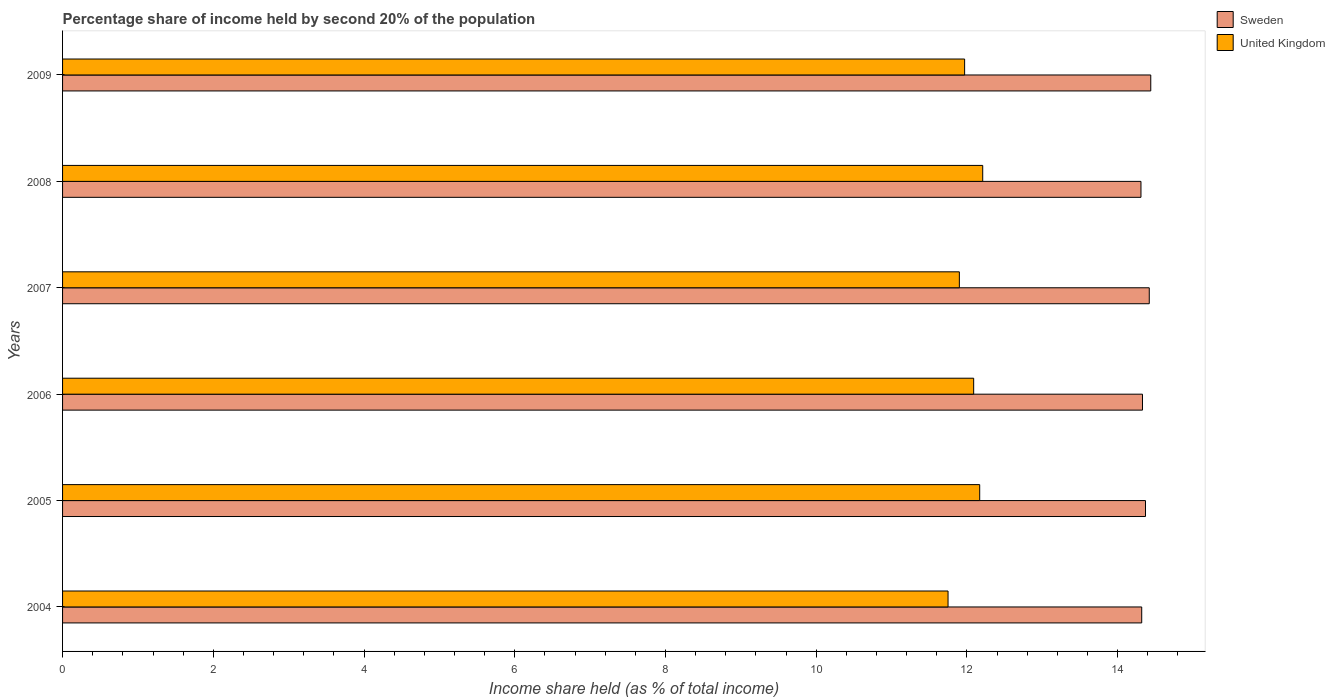How many different coloured bars are there?
Offer a very short reply. 2. How many groups of bars are there?
Your answer should be very brief. 6. Are the number of bars on each tick of the Y-axis equal?
Keep it short and to the point. Yes. How many bars are there on the 5th tick from the top?
Ensure brevity in your answer.  2. How many bars are there on the 5th tick from the bottom?
Your response must be concise. 2. In how many cases, is the number of bars for a given year not equal to the number of legend labels?
Keep it short and to the point. 0. What is the share of income held by second 20% of the population in Sweden in 2004?
Your response must be concise. 14.32. Across all years, what is the maximum share of income held by second 20% of the population in Sweden?
Offer a terse response. 14.44. Across all years, what is the minimum share of income held by second 20% of the population in United Kingdom?
Ensure brevity in your answer.  11.75. In which year was the share of income held by second 20% of the population in United Kingdom minimum?
Ensure brevity in your answer.  2004. What is the total share of income held by second 20% of the population in United Kingdom in the graph?
Offer a terse response. 72.09. What is the difference between the share of income held by second 20% of the population in United Kingdom in 2005 and that in 2008?
Offer a terse response. -0.04. What is the difference between the share of income held by second 20% of the population in United Kingdom in 2008 and the share of income held by second 20% of the population in Sweden in 2007?
Ensure brevity in your answer.  -2.21. What is the average share of income held by second 20% of the population in United Kingdom per year?
Make the answer very short. 12.02. In the year 2008, what is the difference between the share of income held by second 20% of the population in United Kingdom and share of income held by second 20% of the population in Sweden?
Offer a very short reply. -2.1. What is the ratio of the share of income held by second 20% of the population in Sweden in 2006 to that in 2008?
Your response must be concise. 1. Is the difference between the share of income held by second 20% of the population in United Kingdom in 2008 and 2009 greater than the difference between the share of income held by second 20% of the population in Sweden in 2008 and 2009?
Ensure brevity in your answer.  Yes. What is the difference between the highest and the second highest share of income held by second 20% of the population in United Kingdom?
Your answer should be compact. 0.04. What is the difference between the highest and the lowest share of income held by second 20% of the population in Sweden?
Your answer should be very brief. 0.13. In how many years, is the share of income held by second 20% of the population in United Kingdom greater than the average share of income held by second 20% of the population in United Kingdom taken over all years?
Your response must be concise. 3. Is the sum of the share of income held by second 20% of the population in Sweden in 2008 and 2009 greater than the maximum share of income held by second 20% of the population in United Kingdom across all years?
Offer a very short reply. Yes. What does the 2nd bar from the top in 2005 represents?
Your response must be concise. Sweden. What does the 1st bar from the bottom in 2008 represents?
Your answer should be very brief. Sweden. Are all the bars in the graph horizontal?
Give a very brief answer. Yes. How are the legend labels stacked?
Provide a succinct answer. Vertical. What is the title of the graph?
Ensure brevity in your answer.  Percentage share of income held by second 20% of the population. What is the label or title of the X-axis?
Your response must be concise. Income share held (as % of total income). What is the label or title of the Y-axis?
Provide a succinct answer. Years. What is the Income share held (as % of total income) in Sweden in 2004?
Your answer should be very brief. 14.32. What is the Income share held (as % of total income) of United Kingdom in 2004?
Your response must be concise. 11.75. What is the Income share held (as % of total income) in Sweden in 2005?
Provide a succinct answer. 14.37. What is the Income share held (as % of total income) in United Kingdom in 2005?
Your answer should be compact. 12.17. What is the Income share held (as % of total income) of Sweden in 2006?
Your response must be concise. 14.33. What is the Income share held (as % of total income) of United Kingdom in 2006?
Your answer should be very brief. 12.09. What is the Income share held (as % of total income) in Sweden in 2007?
Your answer should be very brief. 14.42. What is the Income share held (as % of total income) of United Kingdom in 2007?
Offer a terse response. 11.9. What is the Income share held (as % of total income) of Sweden in 2008?
Make the answer very short. 14.31. What is the Income share held (as % of total income) in United Kingdom in 2008?
Offer a terse response. 12.21. What is the Income share held (as % of total income) in Sweden in 2009?
Give a very brief answer. 14.44. What is the Income share held (as % of total income) of United Kingdom in 2009?
Offer a terse response. 11.97. Across all years, what is the maximum Income share held (as % of total income) in Sweden?
Your response must be concise. 14.44. Across all years, what is the maximum Income share held (as % of total income) of United Kingdom?
Your answer should be very brief. 12.21. Across all years, what is the minimum Income share held (as % of total income) of Sweden?
Your response must be concise. 14.31. Across all years, what is the minimum Income share held (as % of total income) in United Kingdom?
Make the answer very short. 11.75. What is the total Income share held (as % of total income) in Sweden in the graph?
Provide a succinct answer. 86.19. What is the total Income share held (as % of total income) of United Kingdom in the graph?
Your answer should be compact. 72.09. What is the difference between the Income share held (as % of total income) of Sweden in 2004 and that in 2005?
Your answer should be compact. -0.05. What is the difference between the Income share held (as % of total income) of United Kingdom in 2004 and that in 2005?
Offer a terse response. -0.42. What is the difference between the Income share held (as % of total income) of Sweden in 2004 and that in 2006?
Give a very brief answer. -0.01. What is the difference between the Income share held (as % of total income) of United Kingdom in 2004 and that in 2006?
Make the answer very short. -0.34. What is the difference between the Income share held (as % of total income) of Sweden in 2004 and that in 2007?
Offer a terse response. -0.1. What is the difference between the Income share held (as % of total income) of United Kingdom in 2004 and that in 2008?
Your answer should be compact. -0.46. What is the difference between the Income share held (as % of total income) in Sweden in 2004 and that in 2009?
Provide a short and direct response. -0.12. What is the difference between the Income share held (as % of total income) in United Kingdom in 2004 and that in 2009?
Your answer should be compact. -0.22. What is the difference between the Income share held (as % of total income) of Sweden in 2005 and that in 2006?
Offer a very short reply. 0.04. What is the difference between the Income share held (as % of total income) in United Kingdom in 2005 and that in 2006?
Offer a very short reply. 0.08. What is the difference between the Income share held (as % of total income) of Sweden in 2005 and that in 2007?
Your response must be concise. -0.05. What is the difference between the Income share held (as % of total income) of United Kingdom in 2005 and that in 2007?
Offer a terse response. 0.27. What is the difference between the Income share held (as % of total income) in Sweden in 2005 and that in 2008?
Keep it short and to the point. 0.06. What is the difference between the Income share held (as % of total income) of United Kingdom in 2005 and that in 2008?
Offer a terse response. -0.04. What is the difference between the Income share held (as % of total income) in Sweden in 2005 and that in 2009?
Offer a terse response. -0.07. What is the difference between the Income share held (as % of total income) of United Kingdom in 2005 and that in 2009?
Your answer should be very brief. 0.2. What is the difference between the Income share held (as % of total income) of Sweden in 2006 and that in 2007?
Provide a succinct answer. -0.09. What is the difference between the Income share held (as % of total income) of United Kingdom in 2006 and that in 2007?
Your response must be concise. 0.19. What is the difference between the Income share held (as % of total income) in United Kingdom in 2006 and that in 2008?
Your response must be concise. -0.12. What is the difference between the Income share held (as % of total income) in Sweden in 2006 and that in 2009?
Offer a very short reply. -0.11. What is the difference between the Income share held (as % of total income) in United Kingdom in 2006 and that in 2009?
Ensure brevity in your answer.  0.12. What is the difference between the Income share held (as % of total income) in Sweden in 2007 and that in 2008?
Keep it short and to the point. 0.11. What is the difference between the Income share held (as % of total income) in United Kingdom in 2007 and that in 2008?
Your answer should be very brief. -0.31. What is the difference between the Income share held (as % of total income) in Sweden in 2007 and that in 2009?
Make the answer very short. -0.02. What is the difference between the Income share held (as % of total income) of United Kingdom in 2007 and that in 2009?
Give a very brief answer. -0.07. What is the difference between the Income share held (as % of total income) of Sweden in 2008 and that in 2009?
Make the answer very short. -0.13. What is the difference between the Income share held (as % of total income) of United Kingdom in 2008 and that in 2009?
Your response must be concise. 0.24. What is the difference between the Income share held (as % of total income) in Sweden in 2004 and the Income share held (as % of total income) in United Kingdom in 2005?
Provide a succinct answer. 2.15. What is the difference between the Income share held (as % of total income) of Sweden in 2004 and the Income share held (as % of total income) of United Kingdom in 2006?
Make the answer very short. 2.23. What is the difference between the Income share held (as % of total income) of Sweden in 2004 and the Income share held (as % of total income) of United Kingdom in 2007?
Ensure brevity in your answer.  2.42. What is the difference between the Income share held (as % of total income) in Sweden in 2004 and the Income share held (as % of total income) in United Kingdom in 2008?
Ensure brevity in your answer.  2.11. What is the difference between the Income share held (as % of total income) in Sweden in 2004 and the Income share held (as % of total income) in United Kingdom in 2009?
Keep it short and to the point. 2.35. What is the difference between the Income share held (as % of total income) in Sweden in 2005 and the Income share held (as % of total income) in United Kingdom in 2006?
Offer a very short reply. 2.28. What is the difference between the Income share held (as % of total income) of Sweden in 2005 and the Income share held (as % of total income) of United Kingdom in 2007?
Your answer should be compact. 2.47. What is the difference between the Income share held (as % of total income) in Sweden in 2005 and the Income share held (as % of total income) in United Kingdom in 2008?
Keep it short and to the point. 2.16. What is the difference between the Income share held (as % of total income) in Sweden in 2006 and the Income share held (as % of total income) in United Kingdom in 2007?
Keep it short and to the point. 2.43. What is the difference between the Income share held (as % of total income) of Sweden in 2006 and the Income share held (as % of total income) of United Kingdom in 2008?
Provide a short and direct response. 2.12. What is the difference between the Income share held (as % of total income) in Sweden in 2006 and the Income share held (as % of total income) in United Kingdom in 2009?
Give a very brief answer. 2.36. What is the difference between the Income share held (as % of total income) in Sweden in 2007 and the Income share held (as % of total income) in United Kingdom in 2008?
Provide a short and direct response. 2.21. What is the difference between the Income share held (as % of total income) of Sweden in 2007 and the Income share held (as % of total income) of United Kingdom in 2009?
Your answer should be compact. 2.45. What is the difference between the Income share held (as % of total income) in Sweden in 2008 and the Income share held (as % of total income) in United Kingdom in 2009?
Provide a short and direct response. 2.34. What is the average Income share held (as % of total income) of Sweden per year?
Offer a terse response. 14.37. What is the average Income share held (as % of total income) of United Kingdom per year?
Your answer should be very brief. 12.02. In the year 2004, what is the difference between the Income share held (as % of total income) of Sweden and Income share held (as % of total income) of United Kingdom?
Make the answer very short. 2.57. In the year 2006, what is the difference between the Income share held (as % of total income) in Sweden and Income share held (as % of total income) in United Kingdom?
Offer a terse response. 2.24. In the year 2007, what is the difference between the Income share held (as % of total income) in Sweden and Income share held (as % of total income) in United Kingdom?
Your response must be concise. 2.52. In the year 2008, what is the difference between the Income share held (as % of total income) in Sweden and Income share held (as % of total income) in United Kingdom?
Provide a short and direct response. 2.1. In the year 2009, what is the difference between the Income share held (as % of total income) in Sweden and Income share held (as % of total income) in United Kingdom?
Your answer should be compact. 2.47. What is the ratio of the Income share held (as % of total income) in United Kingdom in 2004 to that in 2005?
Your answer should be very brief. 0.97. What is the ratio of the Income share held (as % of total income) of Sweden in 2004 to that in 2006?
Make the answer very short. 1. What is the ratio of the Income share held (as % of total income) of United Kingdom in 2004 to that in 2006?
Give a very brief answer. 0.97. What is the ratio of the Income share held (as % of total income) in Sweden in 2004 to that in 2007?
Offer a terse response. 0.99. What is the ratio of the Income share held (as % of total income) of United Kingdom in 2004 to that in 2007?
Provide a short and direct response. 0.99. What is the ratio of the Income share held (as % of total income) in Sweden in 2004 to that in 2008?
Make the answer very short. 1. What is the ratio of the Income share held (as % of total income) in United Kingdom in 2004 to that in 2008?
Make the answer very short. 0.96. What is the ratio of the Income share held (as % of total income) of Sweden in 2004 to that in 2009?
Offer a very short reply. 0.99. What is the ratio of the Income share held (as % of total income) in United Kingdom in 2004 to that in 2009?
Offer a terse response. 0.98. What is the ratio of the Income share held (as % of total income) of Sweden in 2005 to that in 2006?
Offer a very short reply. 1. What is the ratio of the Income share held (as % of total income) of United Kingdom in 2005 to that in 2006?
Offer a very short reply. 1.01. What is the ratio of the Income share held (as % of total income) in United Kingdom in 2005 to that in 2007?
Ensure brevity in your answer.  1.02. What is the ratio of the Income share held (as % of total income) in United Kingdom in 2005 to that in 2008?
Your answer should be very brief. 1. What is the ratio of the Income share held (as % of total income) in United Kingdom in 2005 to that in 2009?
Your answer should be compact. 1.02. What is the ratio of the Income share held (as % of total income) of United Kingdom in 2006 to that in 2007?
Offer a terse response. 1.02. What is the ratio of the Income share held (as % of total income) of Sweden in 2006 to that in 2008?
Your answer should be very brief. 1. What is the ratio of the Income share held (as % of total income) of United Kingdom in 2006 to that in 2008?
Your response must be concise. 0.99. What is the ratio of the Income share held (as % of total income) of Sweden in 2006 to that in 2009?
Ensure brevity in your answer.  0.99. What is the ratio of the Income share held (as % of total income) of Sweden in 2007 to that in 2008?
Keep it short and to the point. 1.01. What is the ratio of the Income share held (as % of total income) in United Kingdom in 2007 to that in 2008?
Provide a short and direct response. 0.97. What is the ratio of the Income share held (as % of total income) of Sweden in 2007 to that in 2009?
Your answer should be very brief. 1. What is the ratio of the Income share held (as % of total income) in United Kingdom in 2007 to that in 2009?
Your response must be concise. 0.99. What is the ratio of the Income share held (as % of total income) of Sweden in 2008 to that in 2009?
Your answer should be compact. 0.99. What is the ratio of the Income share held (as % of total income) of United Kingdom in 2008 to that in 2009?
Your answer should be very brief. 1.02. What is the difference between the highest and the second highest Income share held (as % of total income) of Sweden?
Your answer should be very brief. 0.02. What is the difference between the highest and the lowest Income share held (as % of total income) of Sweden?
Offer a terse response. 0.13. What is the difference between the highest and the lowest Income share held (as % of total income) of United Kingdom?
Your response must be concise. 0.46. 